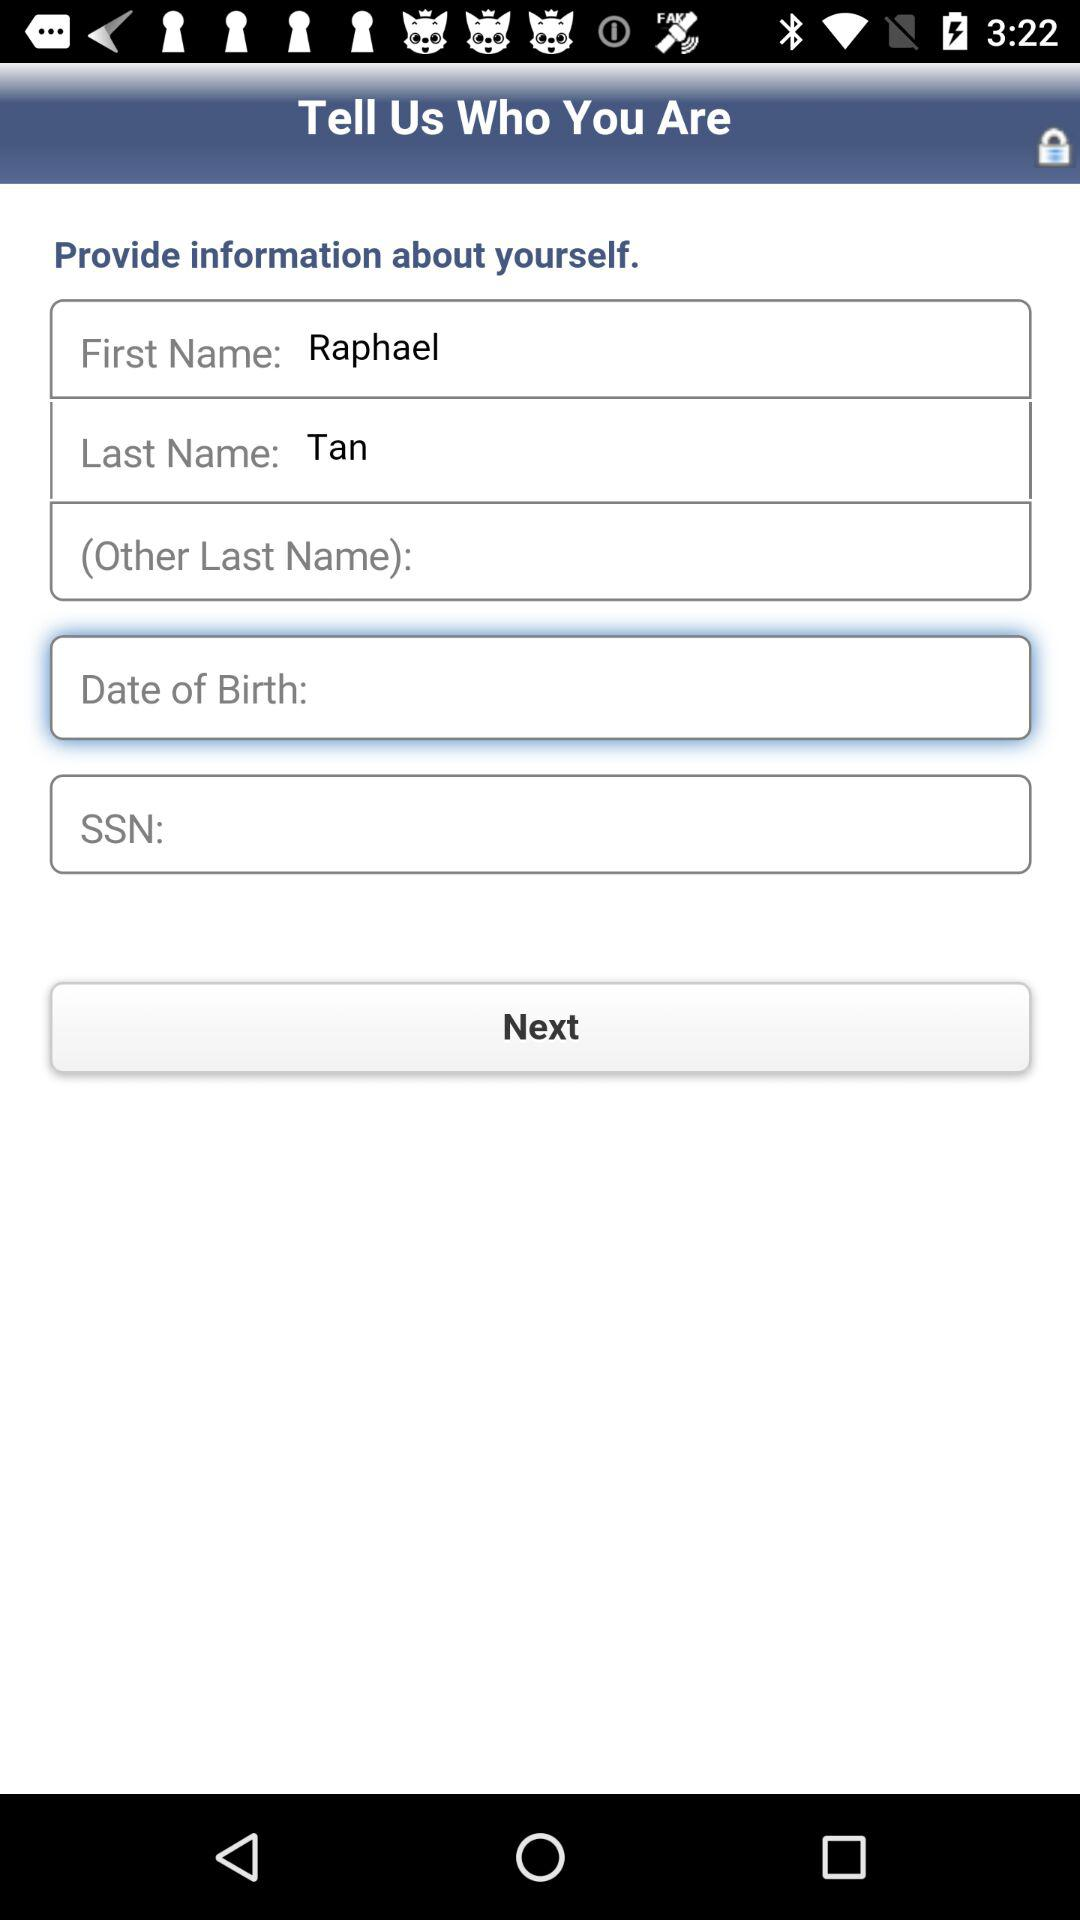What's the last name? The last name is Tan. 